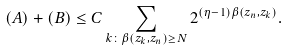Convert formula to latex. <formula><loc_0><loc_0><loc_500><loc_500>( A ) + ( B ) \leq C \sum _ { k \colon \beta ( z _ { k } , z _ { n } ) \geq N } 2 ^ { ( \eta - 1 ) \beta ( z _ { n } , z _ { k } ) } .</formula> 